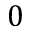<formula> <loc_0><loc_0><loc_500><loc_500>0</formula> 